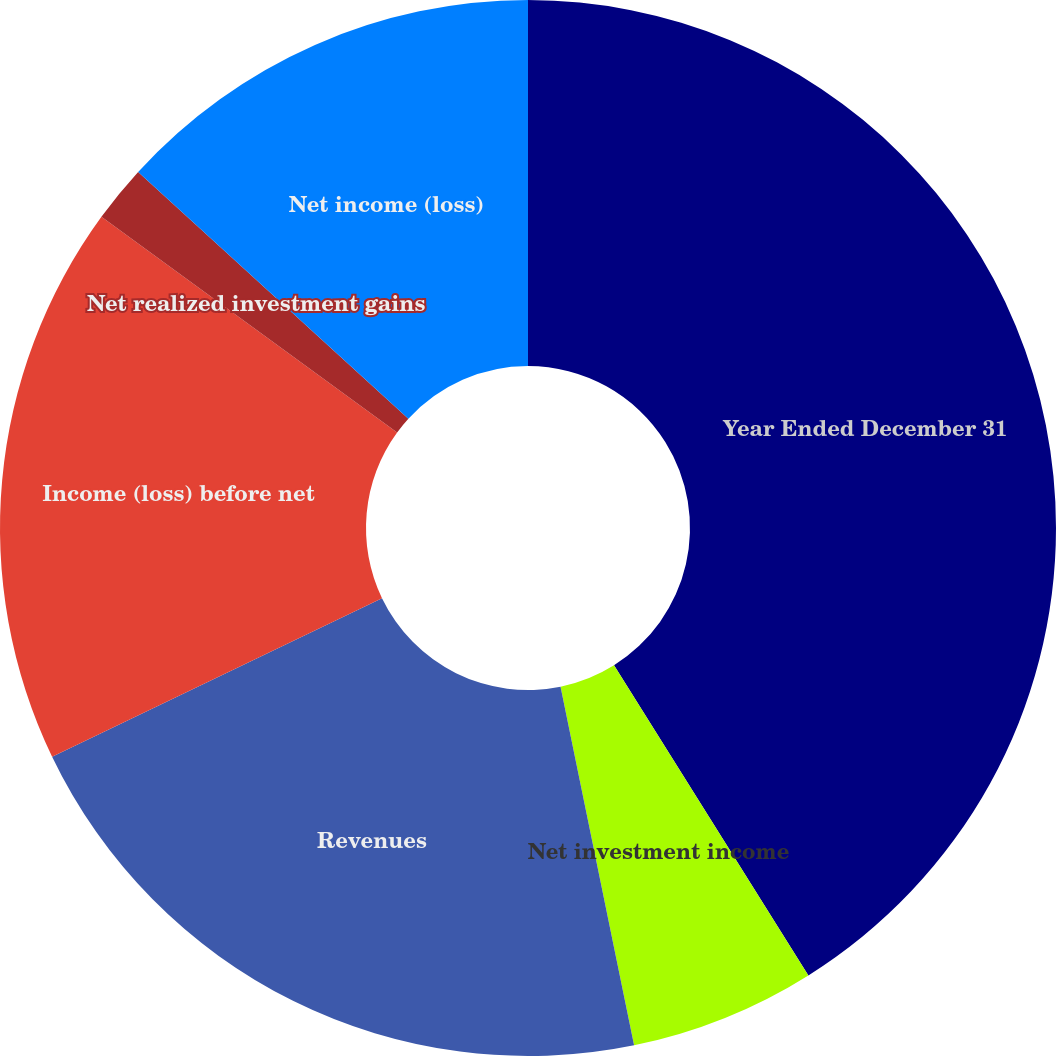Convert chart to OTSL. <chart><loc_0><loc_0><loc_500><loc_500><pie_chart><fcel>Year Ended December 31<fcel>Net investment income<fcel>Revenues<fcel>Income (loss) before net<fcel>Net realized investment gains<fcel>Net income (loss)<nl><fcel>41.09%<fcel>5.69%<fcel>21.09%<fcel>17.16%<fcel>1.75%<fcel>13.22%<nl></chart> 